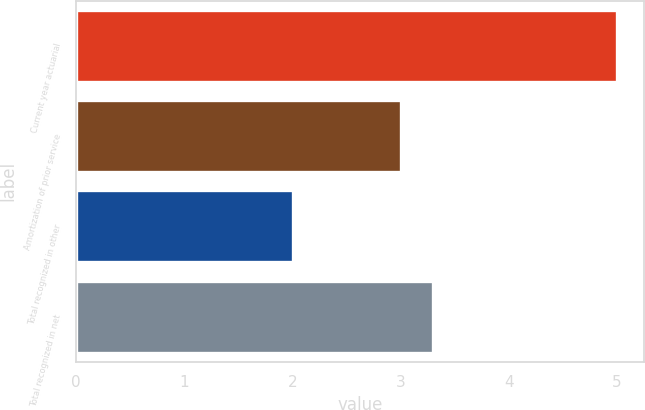<chart> <loc_0><loc_0><loc_500><loc_500><bar_chart><fcel>Current year actuarial<fcel>Amortization of prior service<fcel>Total recognized in other<fcel>Total recognized in net<nl><fcel>5<fcel>3<fcel>2<fcel>3.3<nl></chart> 